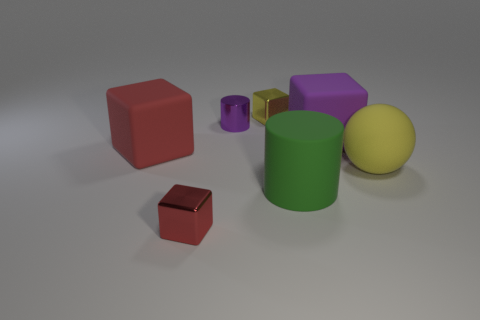Are there any other things that have the same shape as the large yellow thing?
Make the answer very short. No. Is the green object the same size as the yellow matte object?
Your response must be concise. Yes. Are there any small metallic objects right of the big purple thing?
Your response must be concise. No. What is the size of the rubber thing that is both behind the yellow rubber object and to the right of the red rubber cube?
Ensure brevity in your answer.  Large. How many objects are either balls or big cylinders?
Make the answer very short. 2. There is a green thing; is it the same size as the shiny block to the left of the yellow cube?
Keep it short and to the point. No. There is a yellow thing that is in front of the big rubber object on the left side of the tiny metal block in front of the green cylinder; how big is it?
Give a very brief answer. Large. Are there any blue rubber cylinders?
Give a very brief answer. No. What material is the large block that is the same color as the tiny shiny cylinder?
Provide a succinct answer. Rubber. How many metal things are the same color as the large rubber ball?
Your answer should be very brief. 1. 